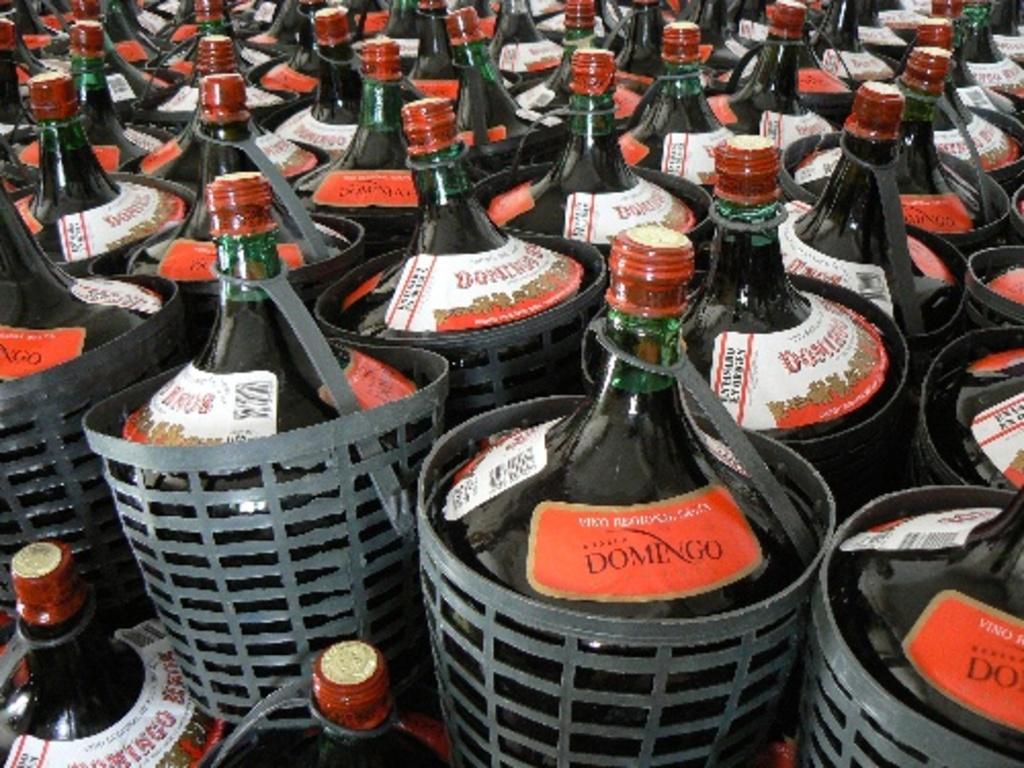What is the brand on the bottle?
Your answer should be compact. Domingo. 